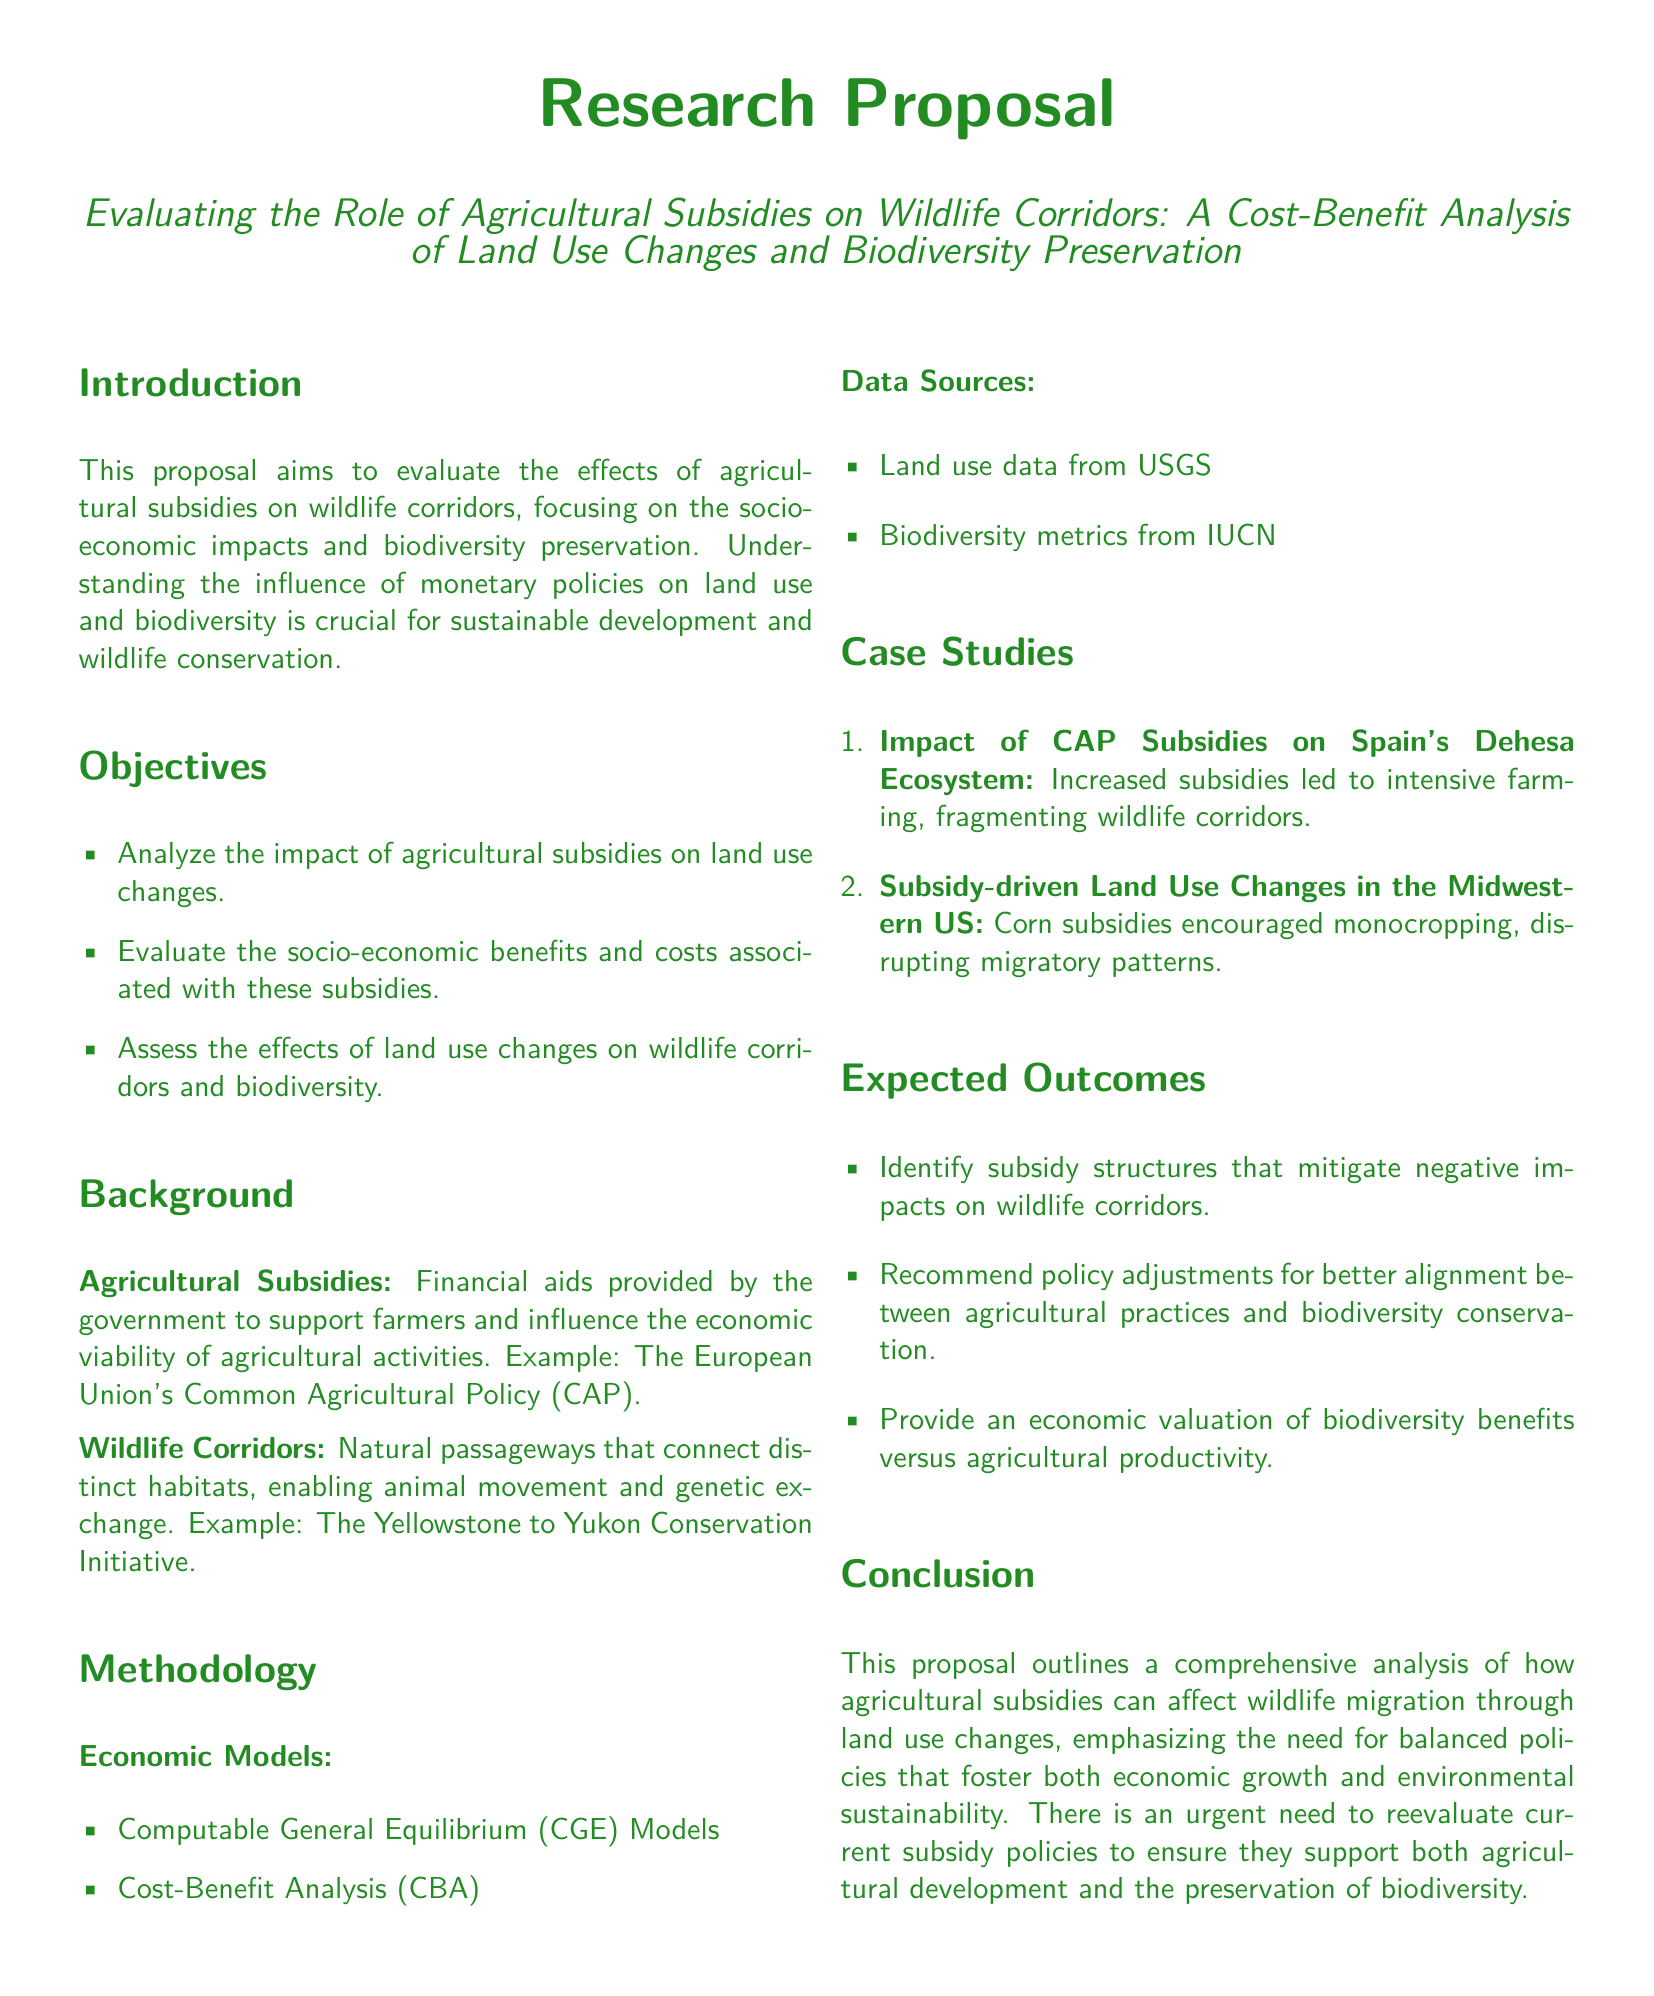What is the title of the proposal? The title provides the main focus of the research.
Answer: Evaluating the Role of Agricultural Subsidies on Wildlife Corridors: A Cost-Benefit Analysis of Land Use Changes and Biodiversity Preservation What type of models will be used in the methodology? The methodology section outlines the economic models to be employed.
Answer: Computable General Equilibrium (CGE) Models What is one example of a wildlife corridor mentioned in the document? The document provides an example to illustrate the concept of wildlife corridors.
Answer: The Yellowstone to Yukon Conservation Initiative What were increased subsidies found to impact in Spain's Dehesa ecosystem? The document specifies the consequences of CAP subsidies in a case study.
Answer: Intensive farming, fragmenting wildlife corridors What is one expected outcome of the research? This part outlines prospective findings based on the study's objectives.
Answer: Identify subsidy structures that mitigate negative impacts on wildlife corridors What is the purpose of agricultural subsidies according to the background? The background section clarifies the role of agricultural subsidies.
Answer: Support farmers and influence the economic viability of agricultural activities How many case studies are mentioned in the proposal? The case studies section lists the examples used for analysis.
Answer: Two What is the aim of the proposal? The introduction states the main objective of the research proposal.
Answer: Evaluate the effects of agricultural subsidies on wildlife corridors 